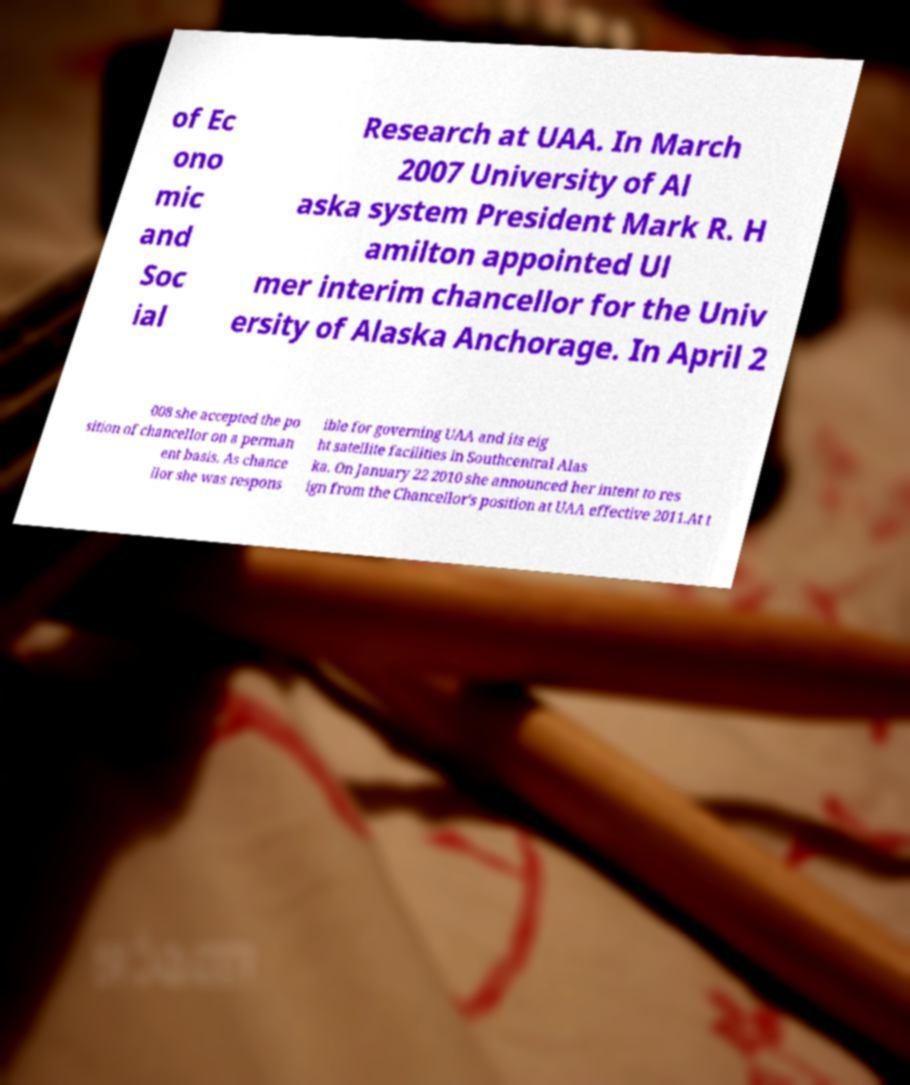For documentation purposes, I need the text within this image transcribed. Could you provide that? of Ec ono mic and Soc ial Research at UAA. In March 2007 University of Al aska system President Mark R. H amilton appointed Ul mer interim chancellor for the Univ ersity of Alaska Anchorage. In April 2 008 she accepted the po sition of chancellor on a perman ent basis. As chance llor she was respons ible for governing UAA and its eig ht satellite facilities in Southcentral Alas ka. On January 22 2010 she announced her intent to res ign from the Chancellor's position at UAA effective 2011.At t 